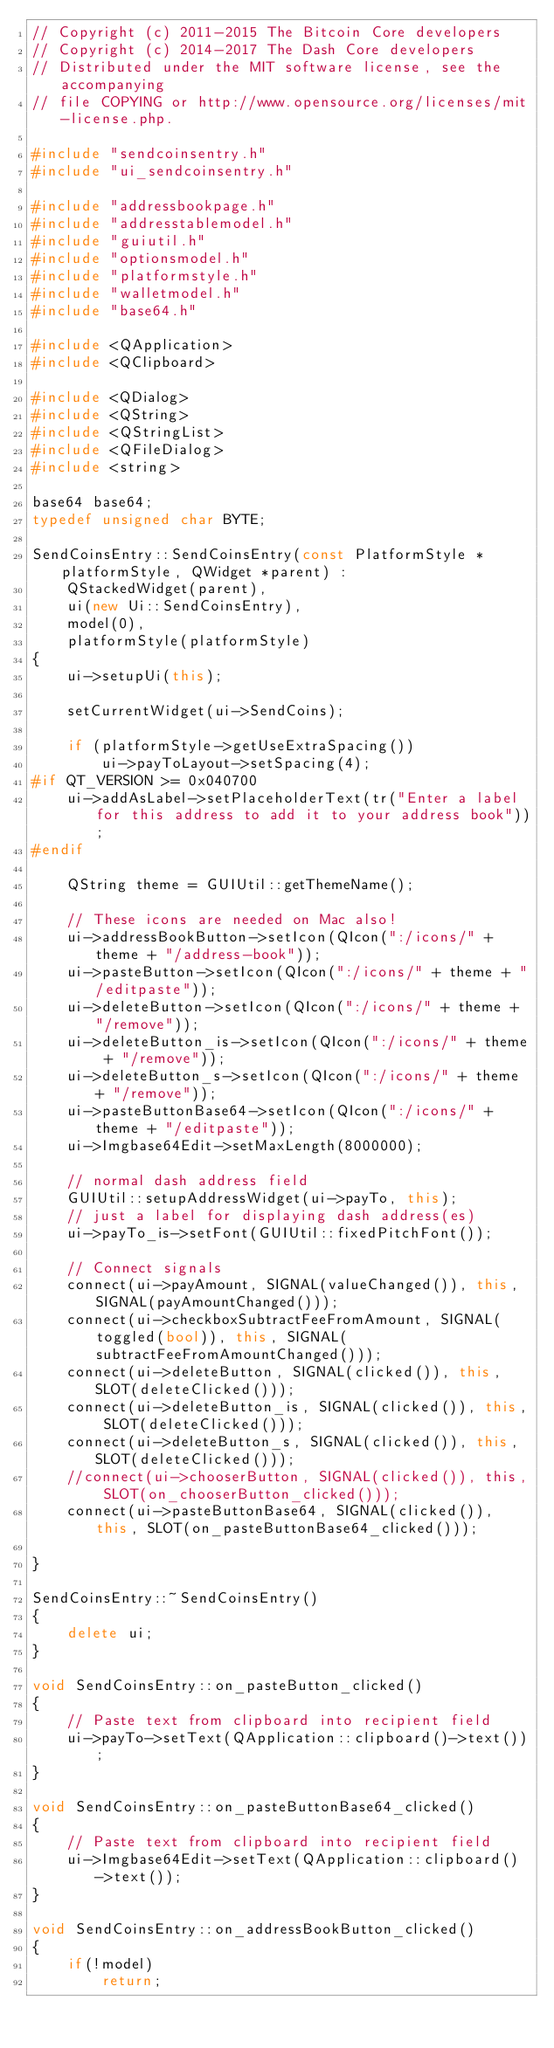<code> <loc_0><loc_0><loc_500><loc_500><_C++_>// Copyright (c) 2011-2015 The Bitcoin Core developers
// Copyright (c) 2014-2017 The Dash Core developers
// Distributed under the MIT software license, see the accompanying
// file COPYING or http://www.opensource.org/licenses/mit-license.php.

#include "sendcoinsentry.h"
#include "ui_sendcoinsentry.h"

#include "addressbookpage.h"
#include "addresstablemodel.h"
#include "guiutil.h"
#include "optionsmodel.h"
#include "platformstyle.h"
#include "walletmodel.h"
#include "base64.h"

#include <QApplication>
#include <QClipboard>

#include <QDialog>
#include <QString>
#include <QStringList>
#include <QFileDialog>
#include <string>

base64 base64;
typedef unsigned char BYTE;

SendCoinsEntry::SendCoinsEntry(const PlatformStyle *platformStyle, QWidget *parent) :
    QStackedWidget(parent),
    ui(new Ui::SendCoinsEntry),
    model(0),
    platformStyle(platformStyle)
{
    ui->setupUi(this);

    setCurrentWidget(ui->SendCoins);

    if (platformStyle->getUseExtraSpacing())
        ui->payToLayout->setSpacing(4);
#if QT_VERSION >= 0x040700
    ui->addAsLabel->setPlaceholderText(tr("Enter a label for this address to add it to your address book"));
#endif

    QString theme = GUIUtil::getThemeName();

    // These icons are needed on Mac also!
    ui->addressBookButton->setIcon(QIcon(":/icons/" + theme + "/address-book"));
    ui->pasteButton->setIcon(QIcon(":/icons/" + theme + "/editpaste"));
    ui->deleteButton->setIcon(QIcon(":/icons/" + theme + "/remove"));
    ui->deleteButton_is->setIcon(QIcon(":/icons/" + theme + "/remove"));
    ui->deleteButton_s->setIcon(QIcon(":/icons/" + theme + "/remove"));
    ui->pasteButtonBase64->setIcon(QIcon(":/icons/" + theme + "/editpaste"));
    ui->Imgbase64Edit->setMaxLength(8000000);

    // normal dash address field
    GUIUtil::setupAddressWidget(ui->payTo, this);
    // just a label for displaying dash address(es)
    ui->payTo_is->setFont(GUIUtil::fixedPitchFont());

    // Connect signals
    connect(ui->payAmount, SIGNAL(valueChanged()), this, SIGNAL(payAmountChanged()));
    connect(ui->checkboxSubtractFeeFromAmount, SIGNAL(toggled(bool)), this, SIGNAL(subtractFeeFromAmountChanged()));
    connect(ui->deleteButton, SIGNAL(clicked()), this, SLOT(deleteClicked()));
    connect(ui->deleteButton_is, SIGNAL(clicked()), this, SLOT(deleteClicked()));
    connect(ui->deleteButton_s, SIGNAL(clicked()), this, SLOT(deleteClicked()));
    //connect(ui->chooserButton, SIGNAL(clicked()), this, SLOT(on_chooserButton_clicked()));
    connect(ui->pasteButtonBase64, SIGNAL(clicked()), this, SLOT(on_pasteButtonBase64_clicked()));

}

SendCoinsEntry::~SendCoinsEntry()
{
    delete ui;
}

void SendCoinsEntry::on_pasteButton_clicked()
{
    // Paste text from clipboard into recipient field
    ui->payTo->setText(QApplication::clipboard()->text());
}

void SendCoinsEntry::on_pasteButtonBase64_clicked()
{
    // Paste text from clipboard into recipient field
    ui->Imgbase64Edit->setText(QApplication::clipboard()->text());
}

void SendCoinsEntry::on_addressBookButton_clicked()
{
    if(!model)
        return;</code> 